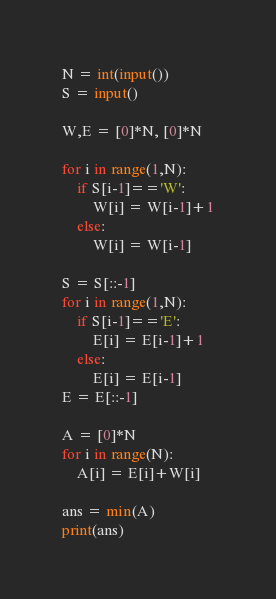<code> <loc_0><loc_0><loc_500><loc_500><_Python_>N = int(input())
S = input()

W,E = [0]*N, [0]*N

for i in range(1,N):
    if S[i-1]=='W':
        W[i] = W[i-1]+1
    else:
        W[i] = W[i-1]

S = S[::-1]
for i in range(1,N):
    if S[i-1]=='E':
        E[i] = E[i-1]+1
    else:
        E[i] = E[i-1]
E = E[::-1]

A = [0]*N
for i in range(N):
    A[i] = E[i]+W[i]

ans = min(A)
print(ans)
</code> 